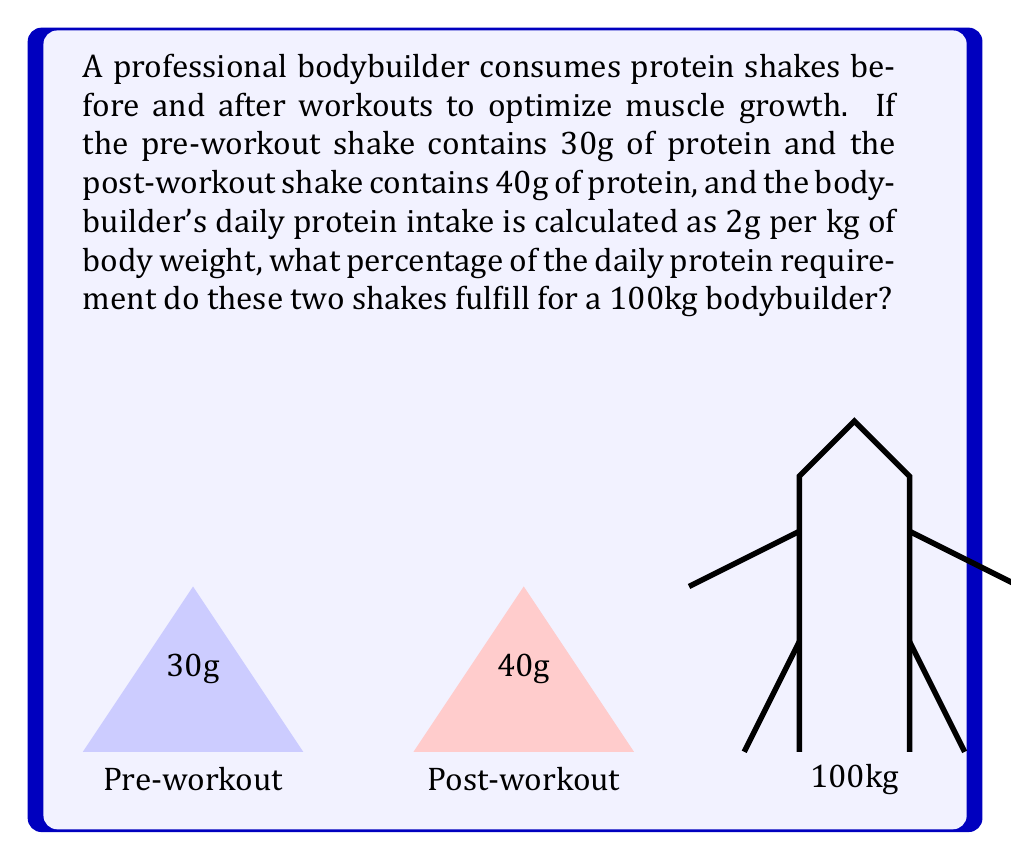Provide a solution to this math problem. Let's break this down step-by-step:

1) First, calculate the bodybuilder's daily protein requirement:
   Daily protein requirement = Body weight × Protein per kg
   $$ 100 \text{ kg} \times 2 \text{ g/kg} = 200 \text{ g} $$

2) Calculate the total protein from both shakes:
   Total shake protein = Pre-workout protein + Post-workout protein
   $$ 30 \text{ g} + 40 \text{ g} = 70 \text{ g} $$

3) To find the percentage, divide the protein from shakes by the daily requirement and multiply by 100:
   $$ \text{Percentage} = \frac{\text{Protein from shakes}}{\text{Daily protein requirement}} \times 100\% $$
   $$ = \frac{70 \text{ g}}{200 \text{ g}} \times 100\% $$
   $$ = 0.35 \times 100\% = 35\% $$

Therefore, the two protein shakes fulfill 35% of the bodybuilder's daily protein requirement.
Answer: 35% 